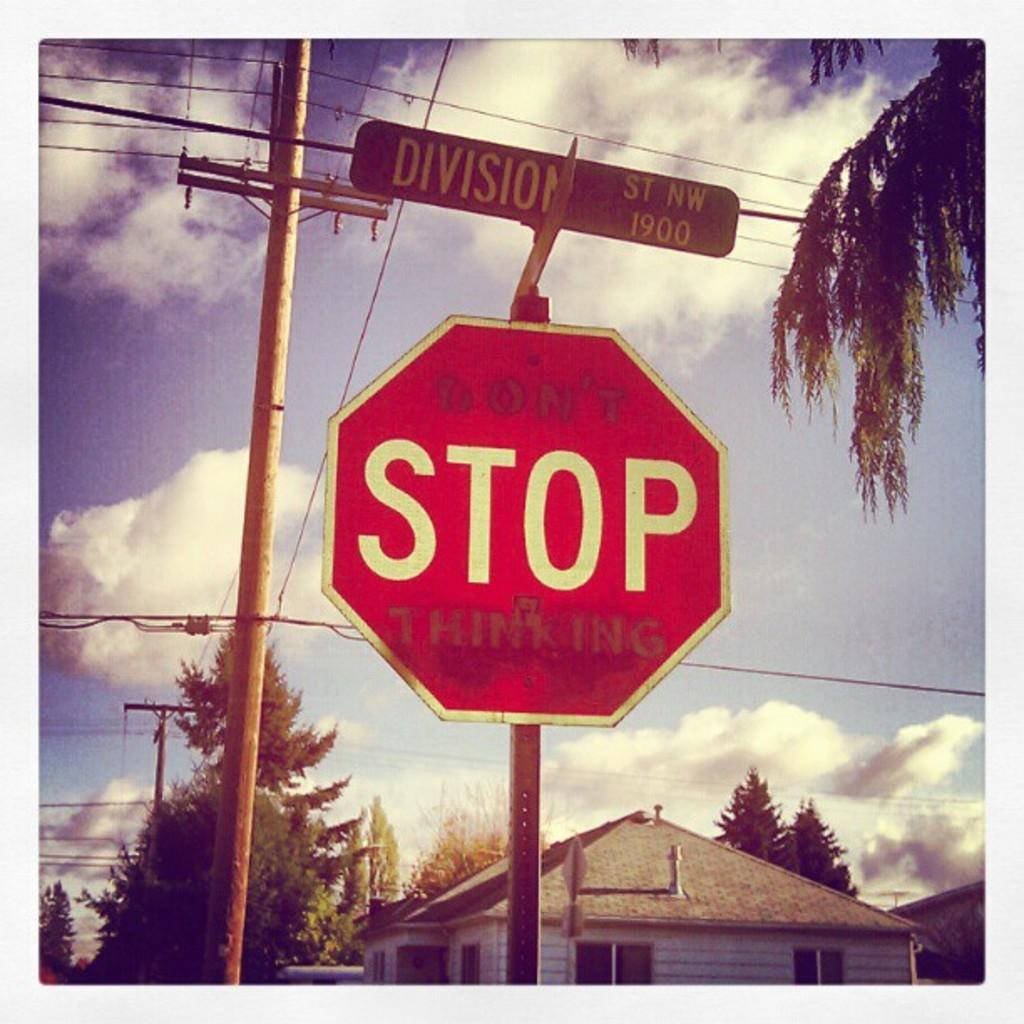<image>
Relay a brief, clear account of the picture shown. A stop sign is sitting under a sign for Division street. 